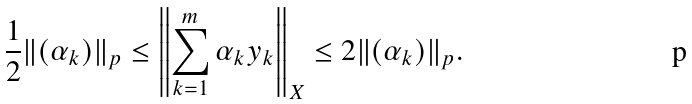<formula> <loc_0><loc_0><loc_500><loc_500>\frac { 1 } { 2 } \| ( \alpha _ { k } ) \| _ { p } \leq \left \| \sum _ { k = 1 } ^ { m } \alpha _ { k } y _ { k } \right \| _ { X } \leq 2 \| ( \alpha _ { k } ) \| _ { p } .</formula> 